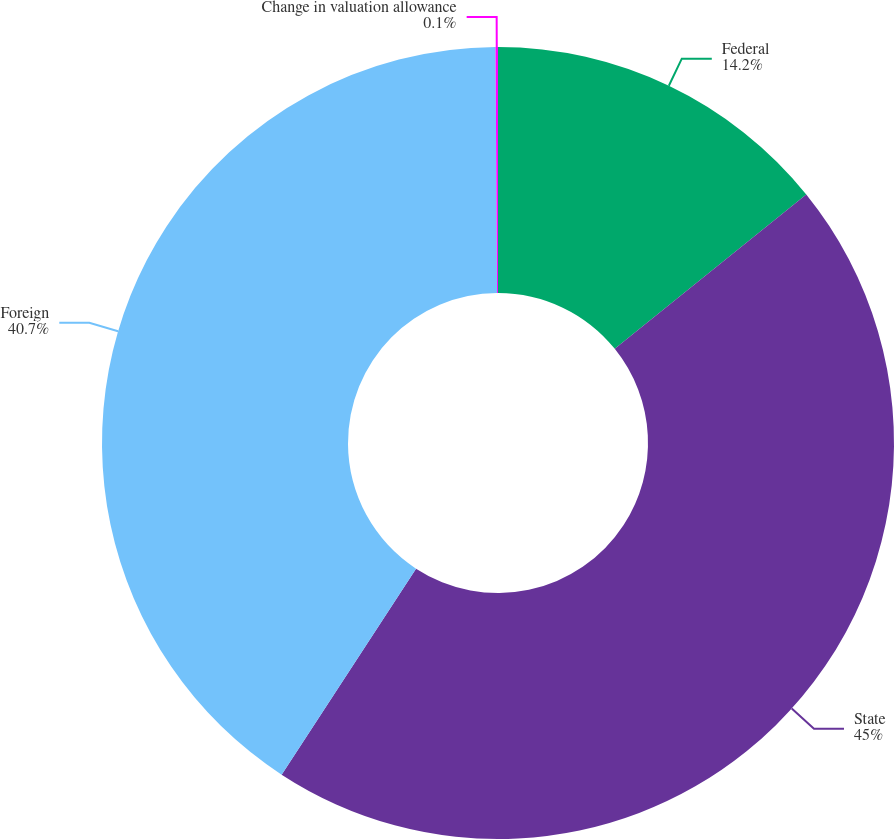Convert chart. <chart><loc_0><loc_0><loc_500><loc_500><pie_chart><fcel>Federal<fcel>State<fcel>Foreign<fcel>Change in valuation allowance<nl><fcel>14.2%<fcel>45.0%<fcel>40.7%<fcel>0.1%<nl></chart> 